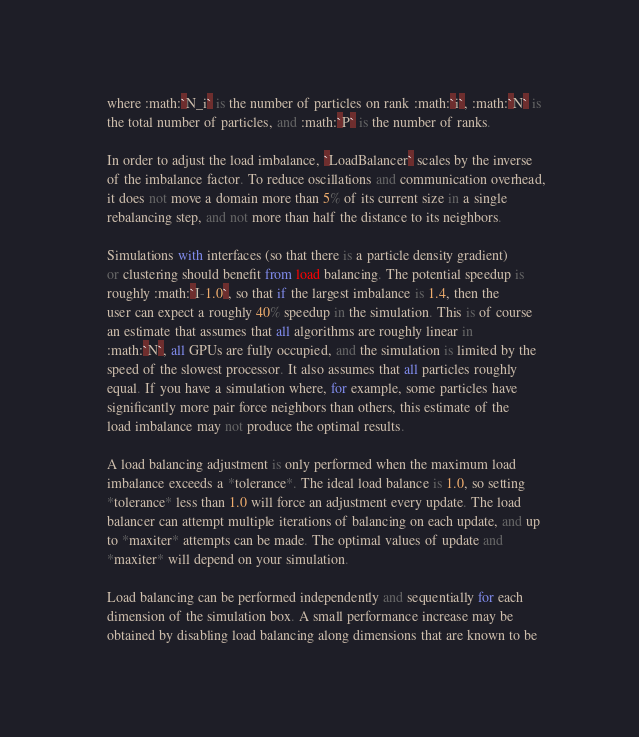Convert code to text. <code><loc_0><loc_0><loc_500><loc_500><_Python_>    where :math:`N_i` is the number of particles on rank :math:`i`, :math:`N` is
    the total number of particles, and :math:`P` is the number of ranks.

    In order to adjust the load imbalance, `LoadBalancer` scales by the inverse
    of the imbalance factor. To reduce oscillations and communication overhead,
    it does not move a domain more than 5% of its current size in a single
    rebalancing step, and not more than half the distance to its neighbors.

    Simulations with interfaces (so that there is a particle density gradient)
    or clustering should benefit from load balancing. The potential speedup is
    roughly :math:`I-1.0`, so that if the largest imbalance is 1.4, then the
    user can expect a roughly 40% speedup in the simulation. This is of course
    an estimate that assumes that all algorithms are roughly linear in
    :math:`N`, all GPUs are fully occupied, and the simulation is limited by the
    speed of the slowest processor. It also assumes that all particles roughly
    equal. If you have a simulation where, for example, some particles have
    significantly more pair force neighbors than others, this estimate of the
    load imbalance may not produce the optimal results.

    A load balancing adjustment is only performed when the maximum load
    imbalance exceeds a *tolerance*. The ideal load balance is 1.0, so setting
    *tolerance* less than 1.0 will force an adjustment every update. The load
    balancer can attempt multiple iterations of balancing on each update, and up
    to *maxiter* attempts can be made. The optimal values of update and
    *maxiter* will depend on your simulation.

    Load balancing can be performed independently and sequentially for each
    dimension of the simulation box. A small performance increase may be
    obtained by disabling load balancing along dimensions that are known to be</code> 